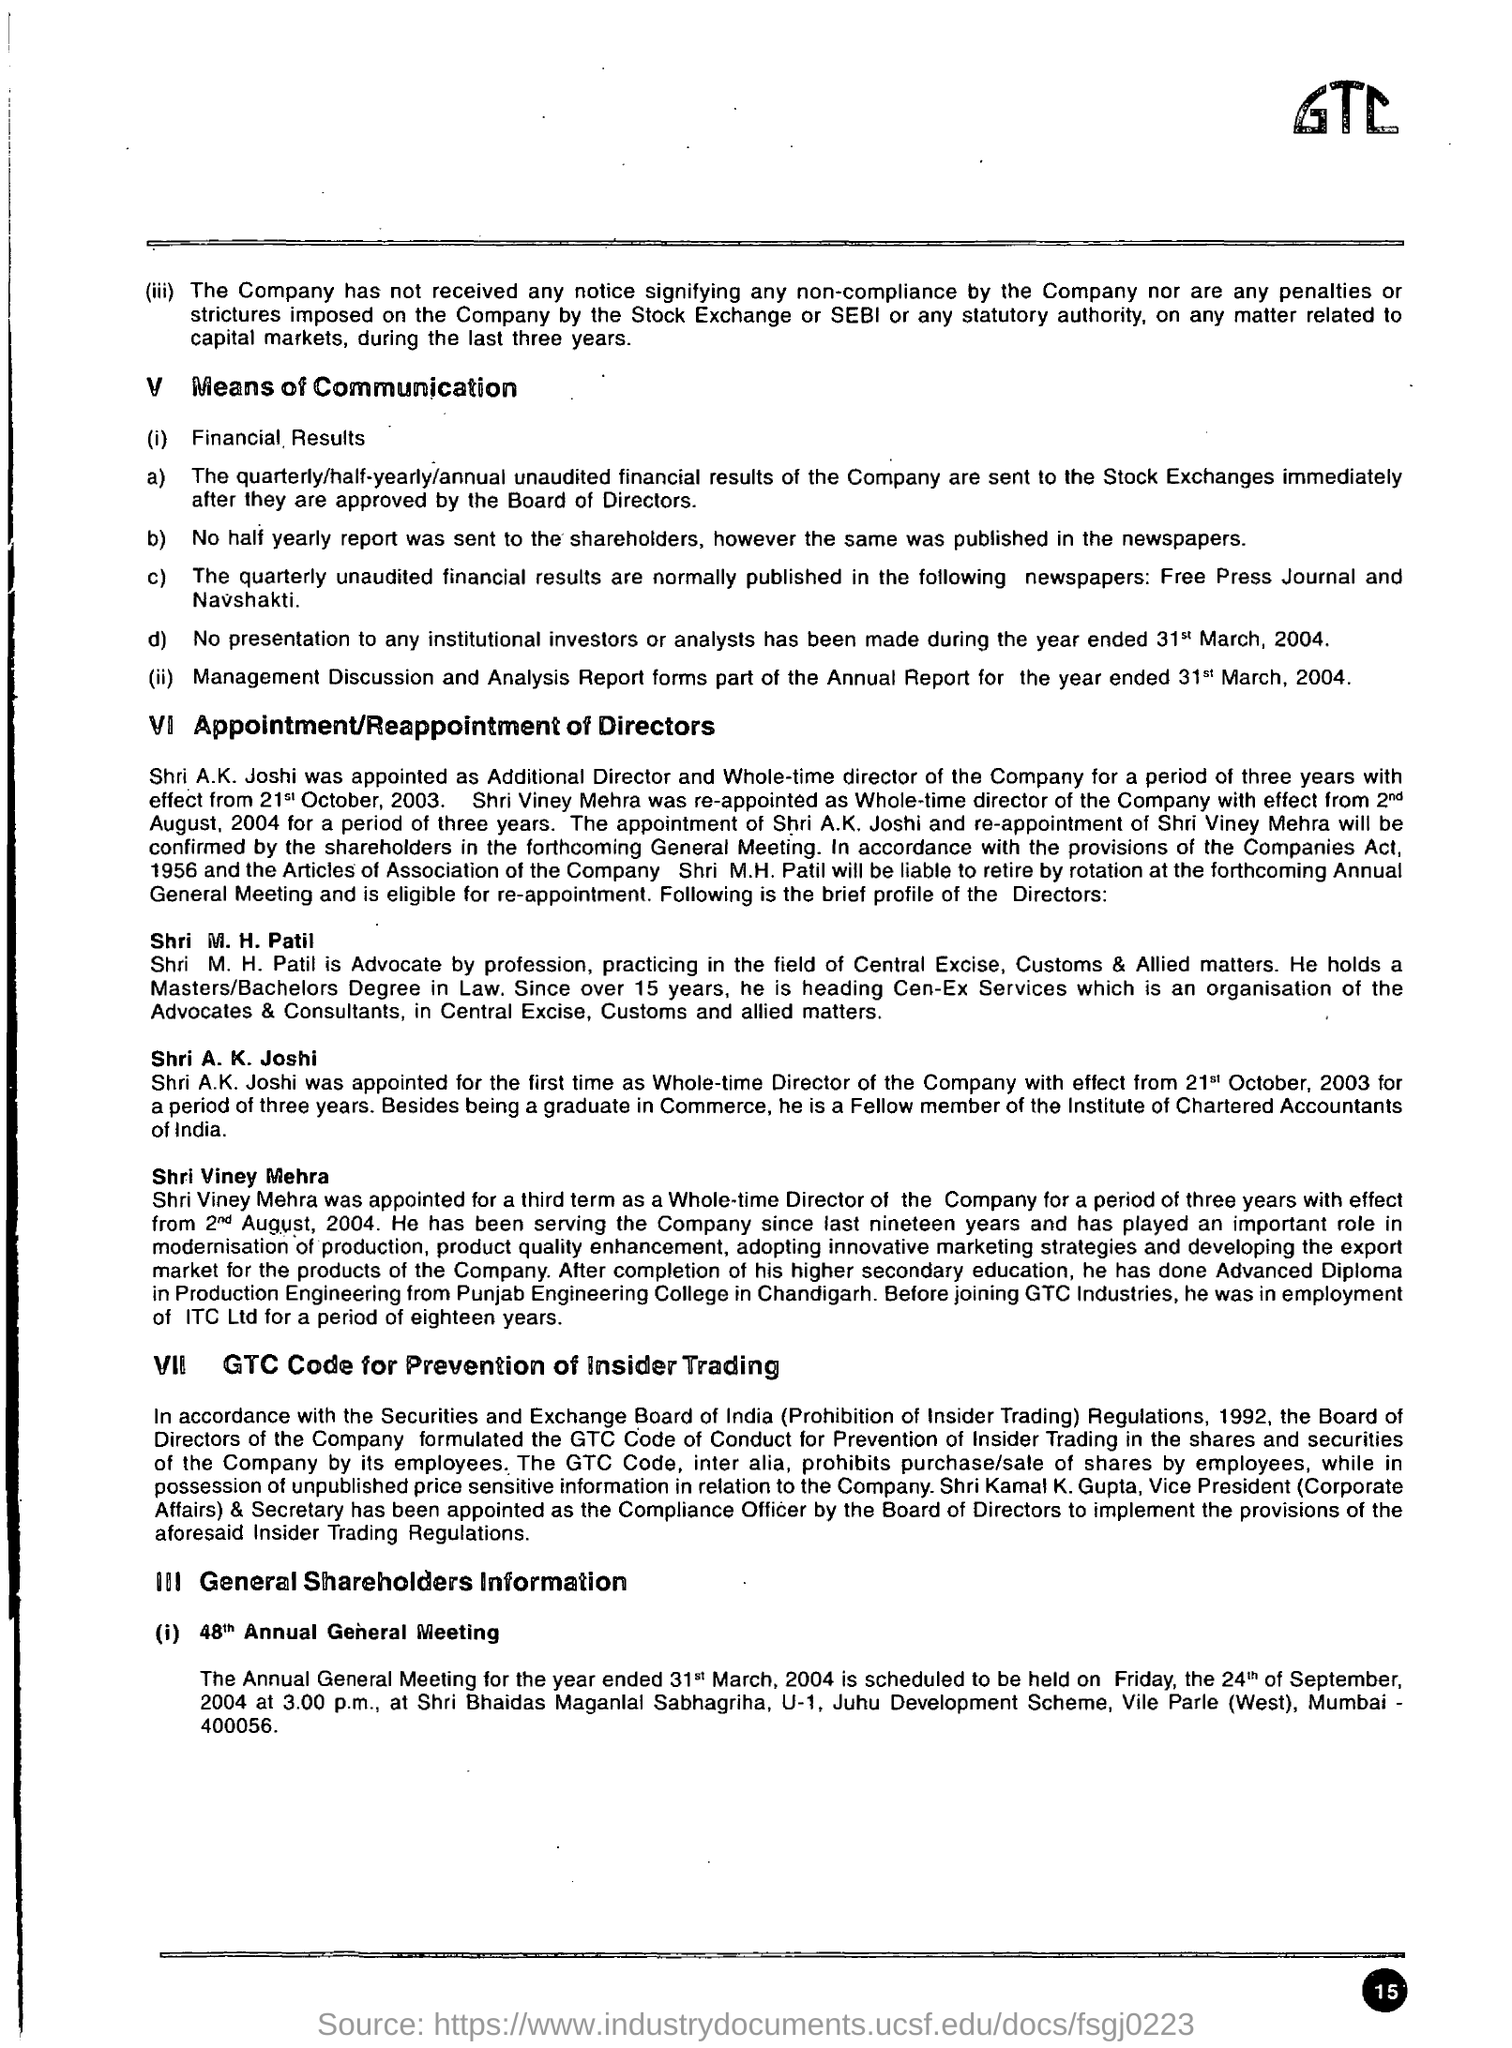What is the name of the company?
Offer a very short reply. GTC. 